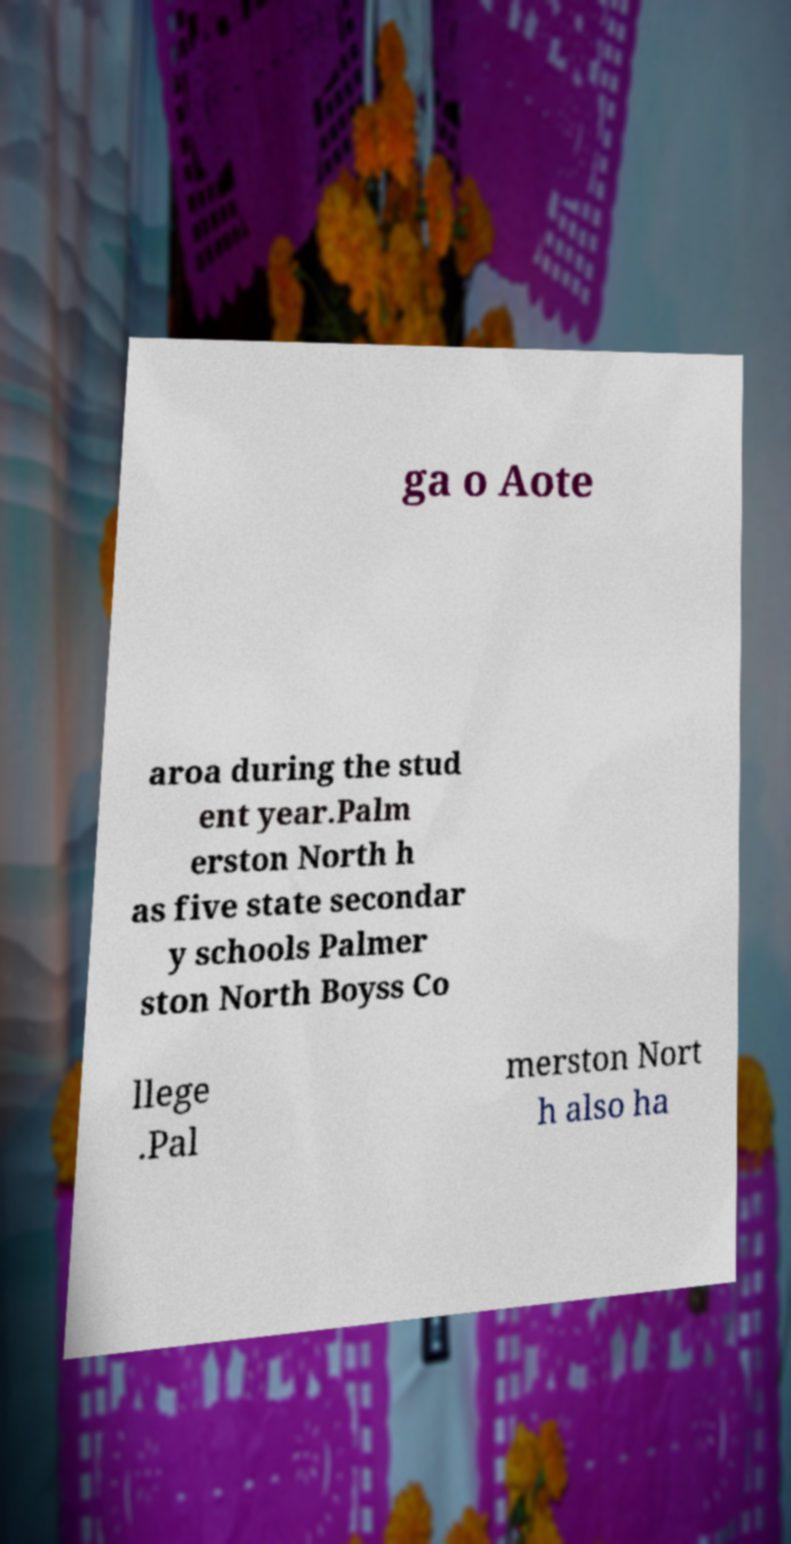I need the written content from this picture converted into text. Can you do that? ga o Aote aroa during the stud ent year.Palm erston North h as five state secondar y schools Palmer ston North Boyss Co llege .Pal merston Nort h also ha 